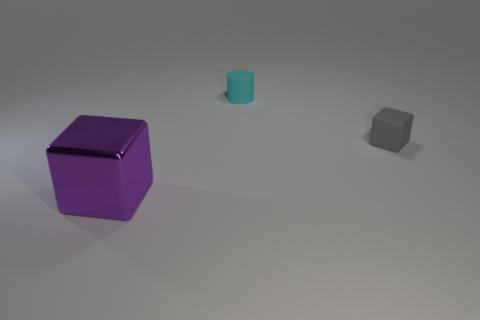Add 1 small red metallic cylinders. How many objects exist? 4 Subtract all cylinders. How many objects are left? 2 Add 1 gray rubber cubes. How many gray rubber cubes exist? 2 Subtract 0 red spheres. How many objects are left? 3 Subtract all cylinders. Subtract all big purple things. How many objects are left? 1 Add 1 cyan matte cylinders. How many cyan matte cylinders are left? 2 